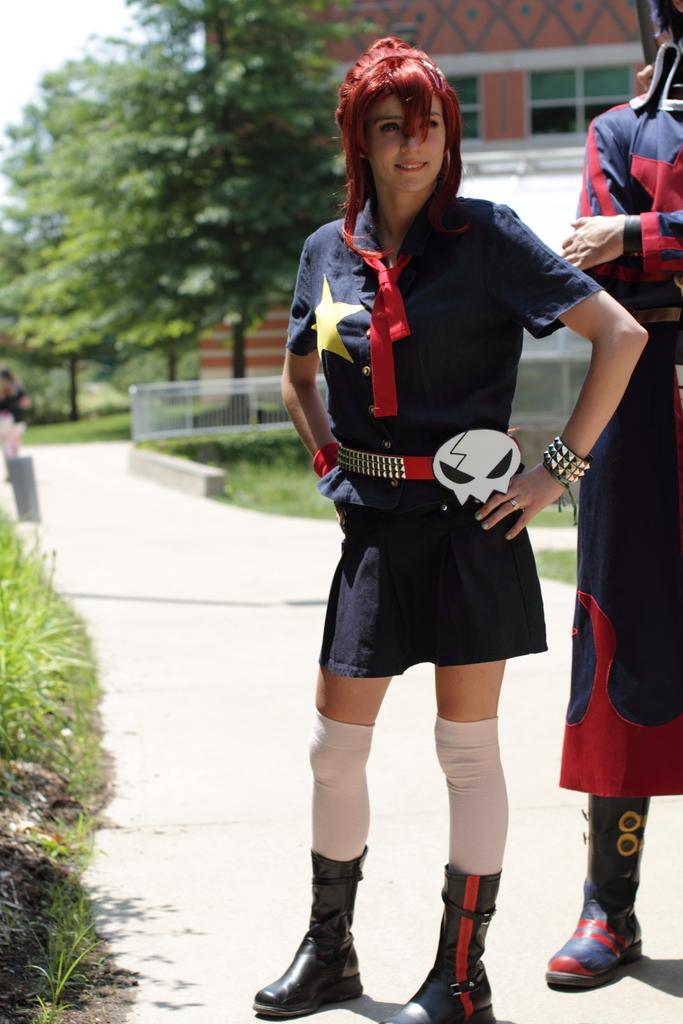Please provide a concise description of this image. In this image, in the middle, we can see a woman wearing a blue color dress is standing on the land. On the right side, we can also see another person standing. On the left side, we can see some plants and a grass. In the background, we can also see a person. In the background, we can see some trees, building, glass window, metal grill. At the top, we can see a sky, at the bottom, we can see a road and a grass. 